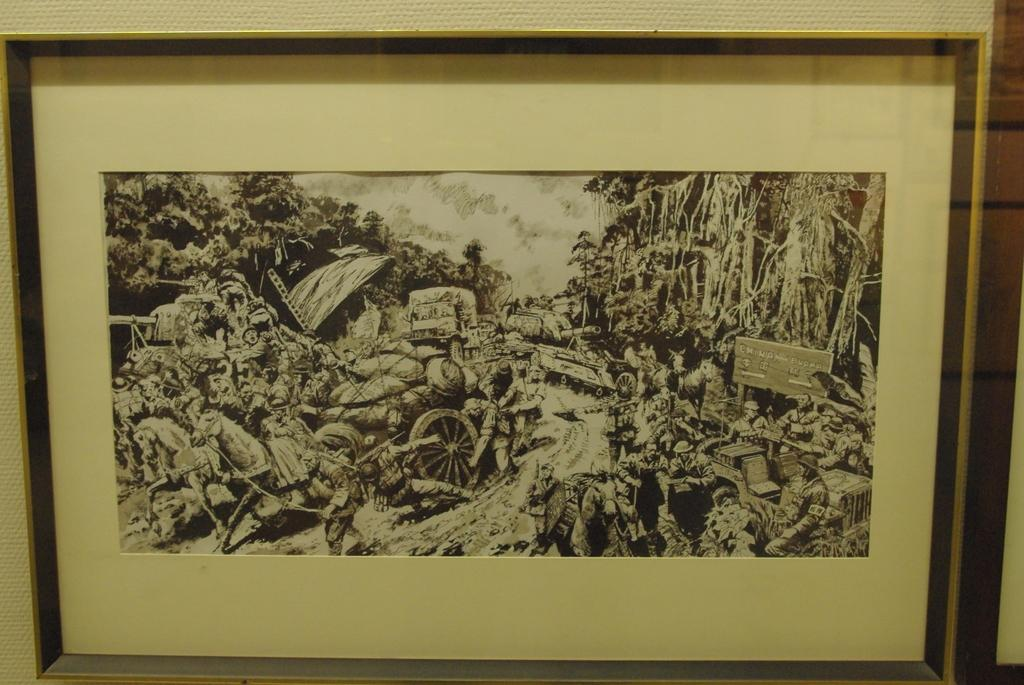What object is present in the image that typically holds images? There is a picture frame in the image. What types of images are contained within the picture frame? The picture frame contains images of trees, horses, and men. What type of knife is being used by the man in the image? There is no knife present in the image; the image contains pictures of men, but they are not depicted using any knives. 